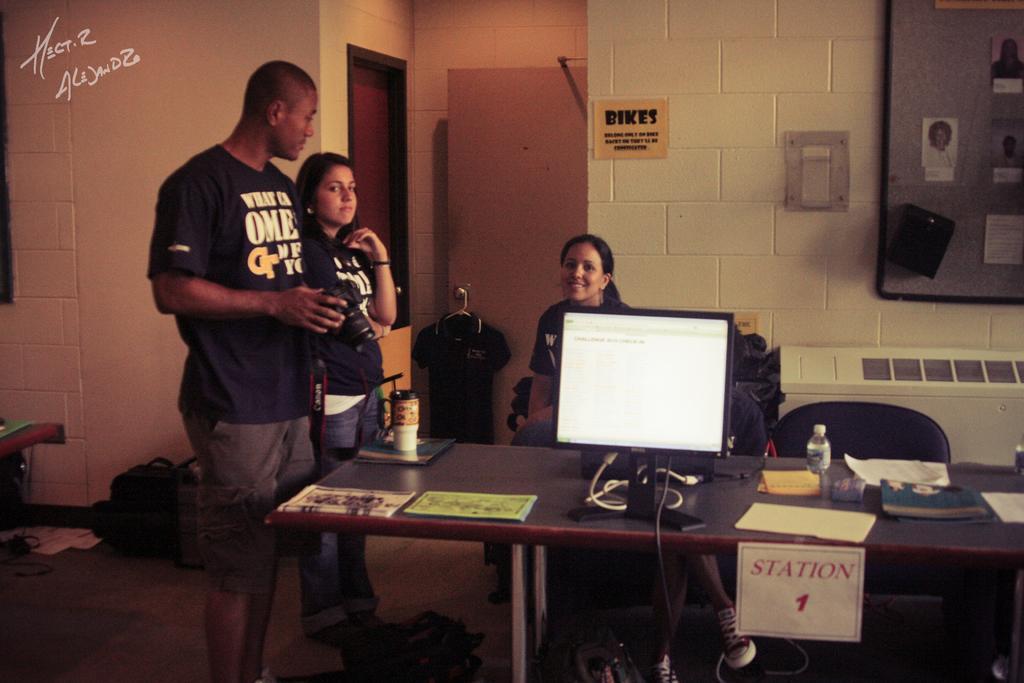Describe this image in one or two sentences. In this image i can see inside view of house and on left side i can see a man wearing a black shirt ,he is standing near to the bench beside another woman standing on the floor. and she wearing a black color shirt and she also standing near to the table on the center there is a table,on the table there is a system ,bottle,book and the paper. back side of the system there is another woman. she is smiling. back side of her there is a hoarding board 